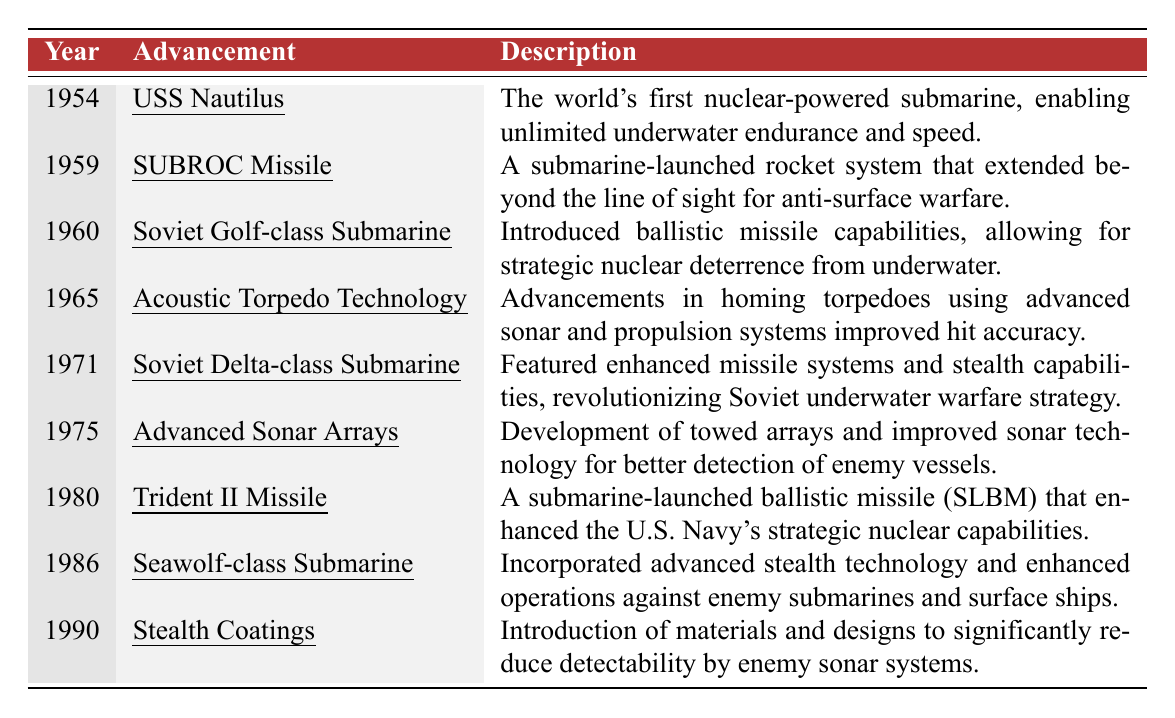What year was the USS Nautilus introduced? The table lists the USS Nautilus under the year 1954, clearly indicating the introduction date.
Answer: 1954 What advancement was introduced in 1975? According to the table, the advancement noted for 1975 is "Advanced Sonar Arrays."
Answer: Advanced Sonar Arrays Did the Soviet Golf-class Submarine have ballistic missile capabilities? The description for the Soviet Golf-class Submarine in the table confirms that it introduced ballistic missile capabilities.
Answer: Yes Which advancement improved hit accuracy for torpedoes? The table specifically mentions "Acoustic Torpedo Technology" as the advancement that included improvements in homing torpedoes for hit accuracy.
Answer: Acoustic Torpedo Technology What is the significance of the USS Nautilus in submarine history? The table describes the USS Nautilus as the world's first nuclear-powered submarine, noting its contribution to unlimited underwater endurance and speed.
Answer: It was the first nuclear-powered submarine Which advancements were made in submarine technology between 1954 and 1965? By reviewing the table from 1954 to 1965, the advancements listed are the USS Nautilus (1954), SUBROC Missile (1959), and Acoustic Torpedo Technology (1965).
Answer: USS Nautilus, SUBROC Missile, Acoustic Torpedo Technology In what year did the U.S. Navy enhance its strategic nuclear capabilities? The entry for 1980 in the table indicates that the Trident II Missile represented an enhancement of the U.S. Navy's strategic nuclear capabilities.
Answer: 1980 How many submarine advancements were introduced between 1970 and 1990? The table mentions advancements for the years 1971, 1975, 1980, 1986, and 1990, totaling 5 advancements within that timeframe.
Answer: 5 advancements Which submarine had advanced stealth technology? The table states that the Seawolf-class Submarine, introduced in 1986, incorporated advanced stealth technology.
Answer: Seawolf-class Submarine What year marked the introduction of stealth coatings in submarine technology? The table indicates that stealth coatings were introduced in 1990, as stated in the last row.
Answer: 1990 Which advancement represented a major development in Soviet underwater warfare strategy, and when was it introduced? The Soviet Delta-class Submarine, noted in 1971, is described as having revolutionized Soviet underwater warfare strategy with enhanced missile systems and stealth capabilities.
Answer: Soviet Delta-class Submarine, 1971 Was the introduction of the SUBROC Missile primarily for anti-surface warfare? The description in the table confirms that the SUBROC Missile was indeed a submarine-launched rocket system designed for anti-surface warfare.
Answer: Yes What is the trend in submarine advancements from 1954 to 1990 in terms of stealth technology? The provided advancements illustrate a clear trend towards improving stealth technology, especially noted in the Soviet Delta-class Submarine (1971), Seawolf-class Submarine (1986), and the introduction of stealth coatings (1990).
Answer: Increased focus on stealth technology 